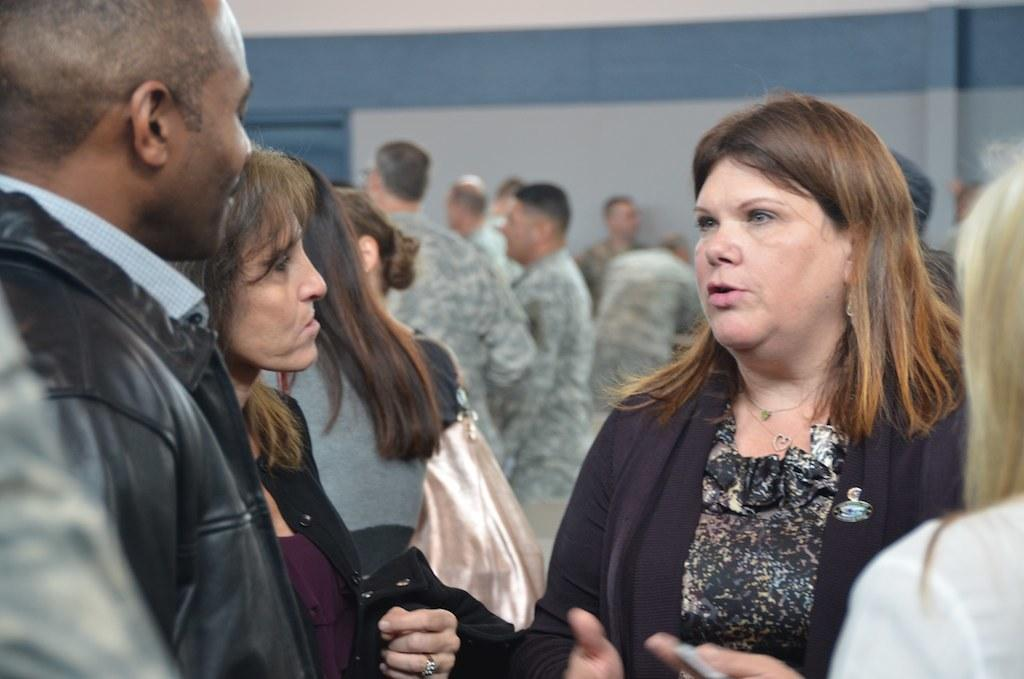How many people are in the image? There are people in the image. Can you describe what one of the ladies is wearing? One lady is wearing a bag. What is another lady holding in the image? Another lady is holding a cloth. What can be seen behind the people in the image? There is a wall visible in the image. How would you describe the background of the image? The background of the image is blurred. How many times does the paste fall from the wall in the image? There is no paste or falling action depicted in the image. 